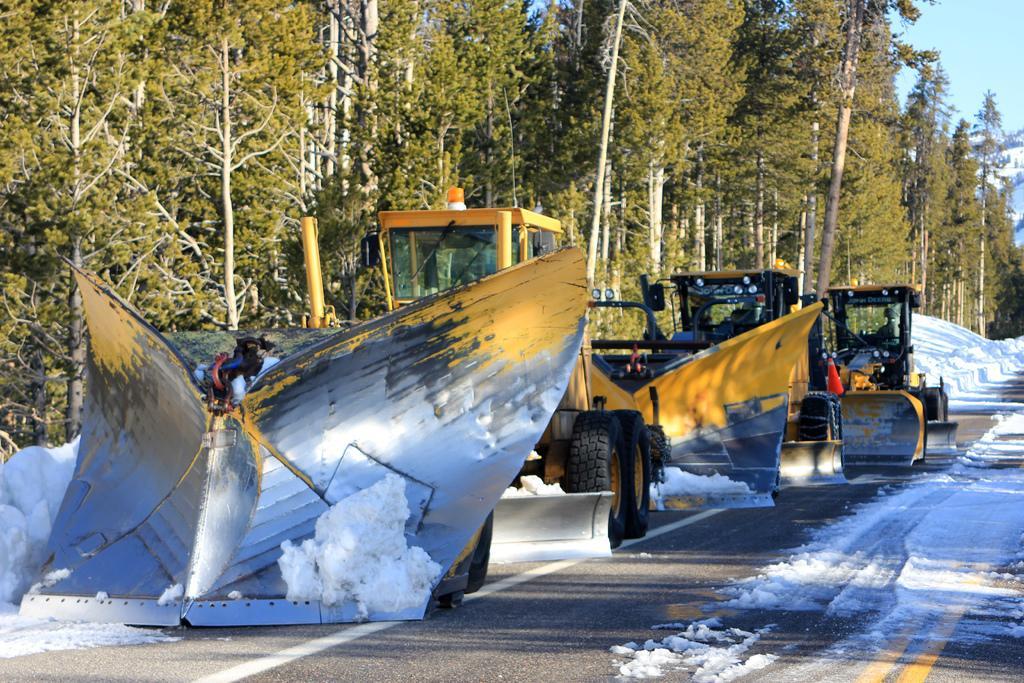Describe this image in one or two sentences. In the middle of the image there are some vehicles on the road. Behind the vehicles there are some trees and snow. In the top right side of the image there are some hills and sky. 